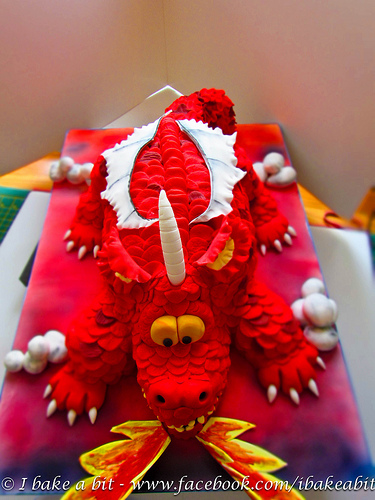<image>
Can you confirm if the dragon is behind the fire? Yes. From this viewpoint, the dragon is positioned behind the fire, with the fire partially or fully occluding the dragon. 